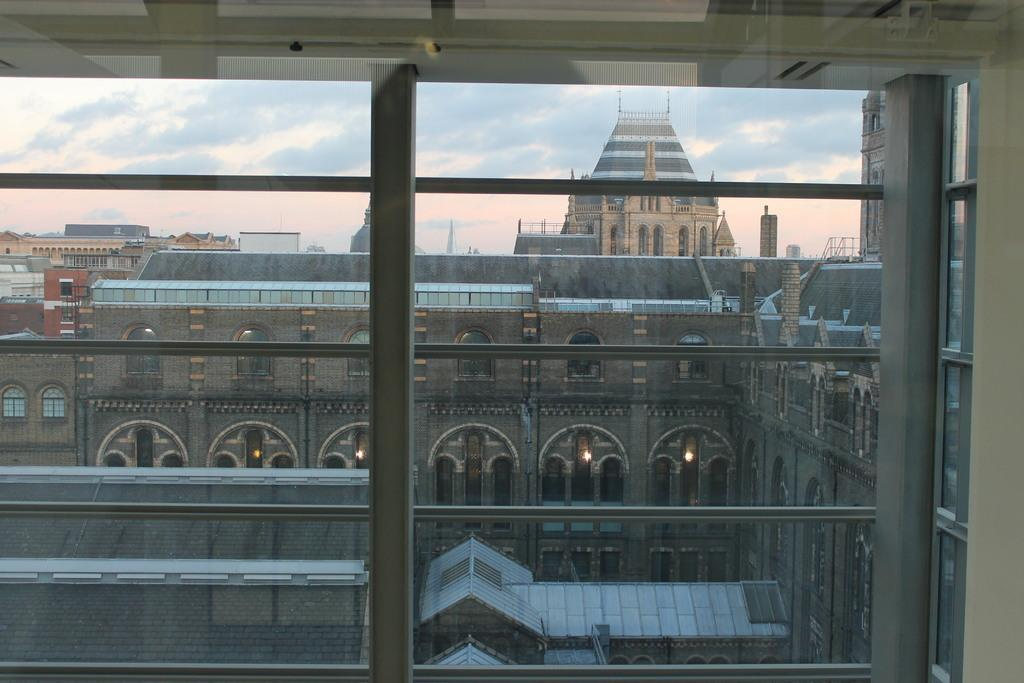What type of structures are present in the image? There are many buildings in the image. What feature do the buildings have in common? The buildings have multiple windows. What can be seen in the background of the image? There is a sky visible in the image. Can you describe a specific detail about one of the buildings? There are fewer lamps in one of the buildings in the image. Can you see a beam of light coming from the snake in the image? There is no snake present in the image, so there cannot be a beam of light coming from it. 